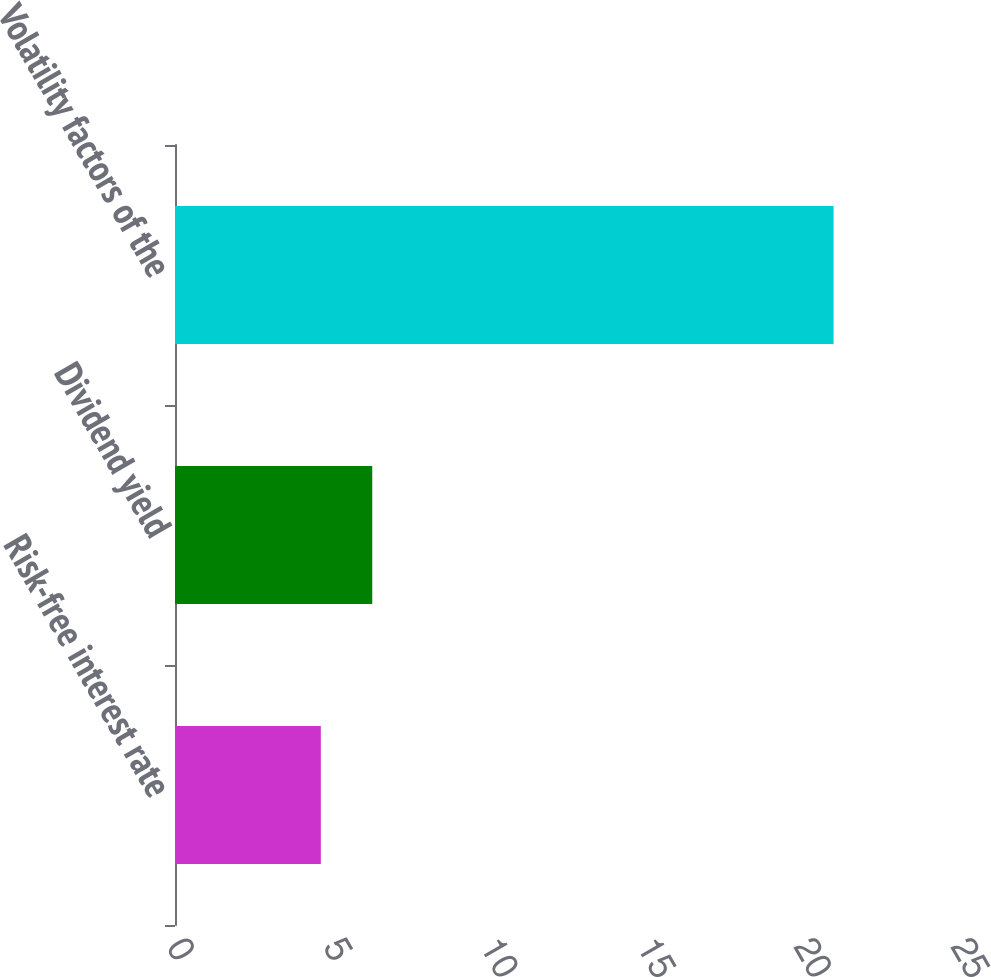Convert chart to OTSL. <chart><loc_0><loc_0><loc_500><loc_500><bar_chart><fcel>Risk-free interest rate<fcel>Dividend yield<fcel>Volatility factors of the<nl><fcel>4.65<fcel>6.29<fcel>21<nl></chart> 